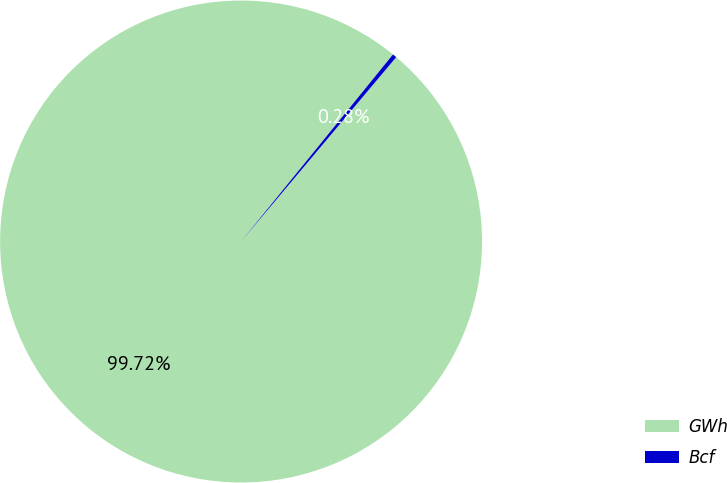Convert chart to OTSL. <chart><loc_0><loc_0><loc_500><loc_500><pie_chart><fcel>GWh<fcel>Bcf<nl><fcel>99.72%<fcel>0.28%<nl></chart> 